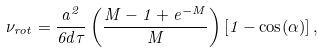<formula> <loc_0><loc_0><loc_500><loc_500>\nu _ { r o t } = \frac { a ^ { 2 } } { 6 d \tau } \left ( \frac { M - 1 + e ^ { - M } } { M } \right ) [ 1 - \cos ( \alpha ) ] \, ,</formula> 